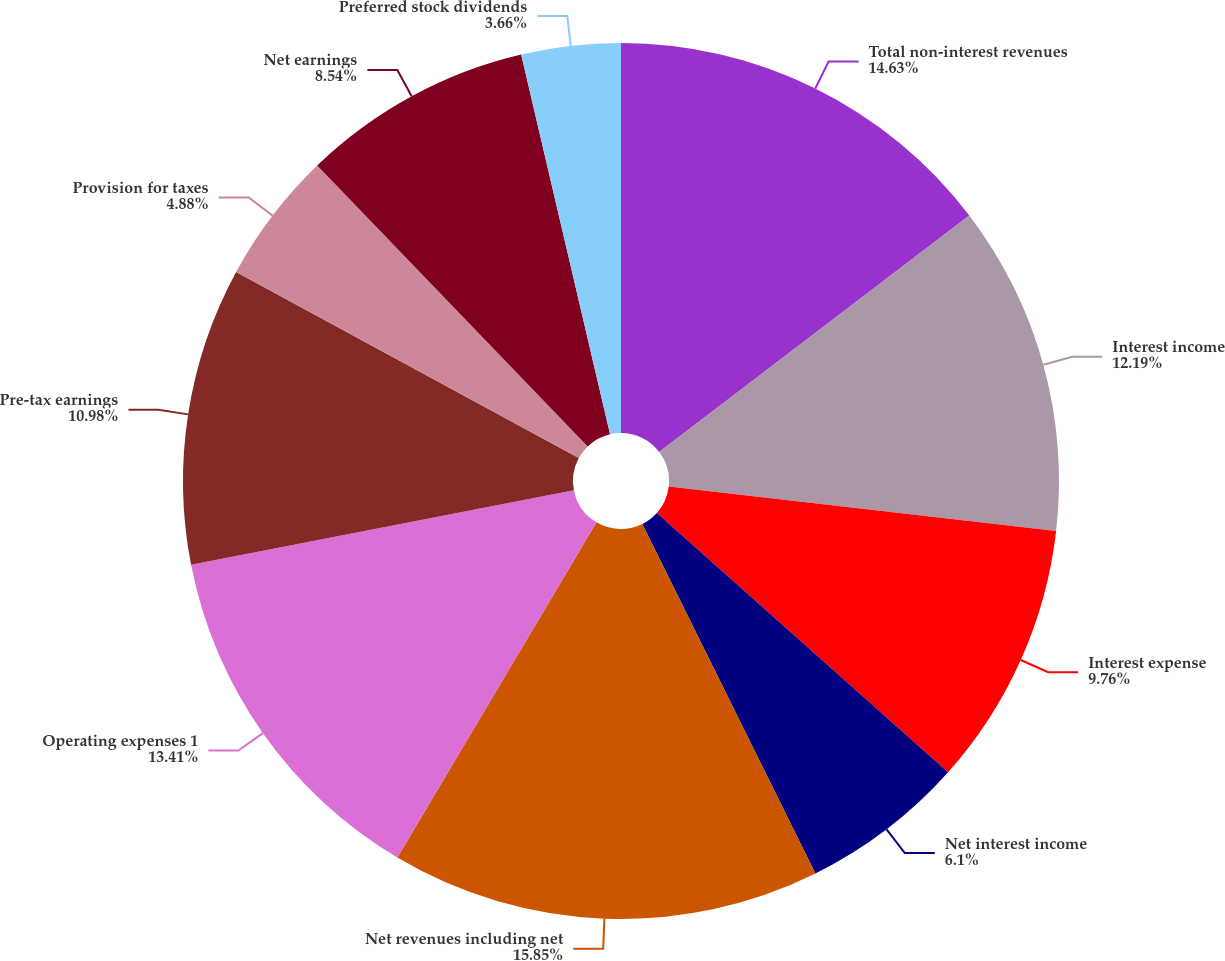Convert chart to OTSL. <chart><loc_0><loc_0><loc_500><loc_500><pie_chart><fcel>Total non-interest revenues<fcel>Interest income<fcel>Interest expense<fcel>Net interest income<fcel>Net revenues including net<fcel>Operating expenses 1<fcel>Pre-tax earnings<fcel>Provision for taxes<fcel>Net earnings<fcel>Preferred stock dividends<nl><fcel>14.63%<fcel>12.19%<fcel>9.76%<fcel>6.1%<fcel>15.85%<fcel>13.41%<fcel>10.98%<fcel>4.88%<fcel>8.54%<fcel>3.66%<nl></chart> 